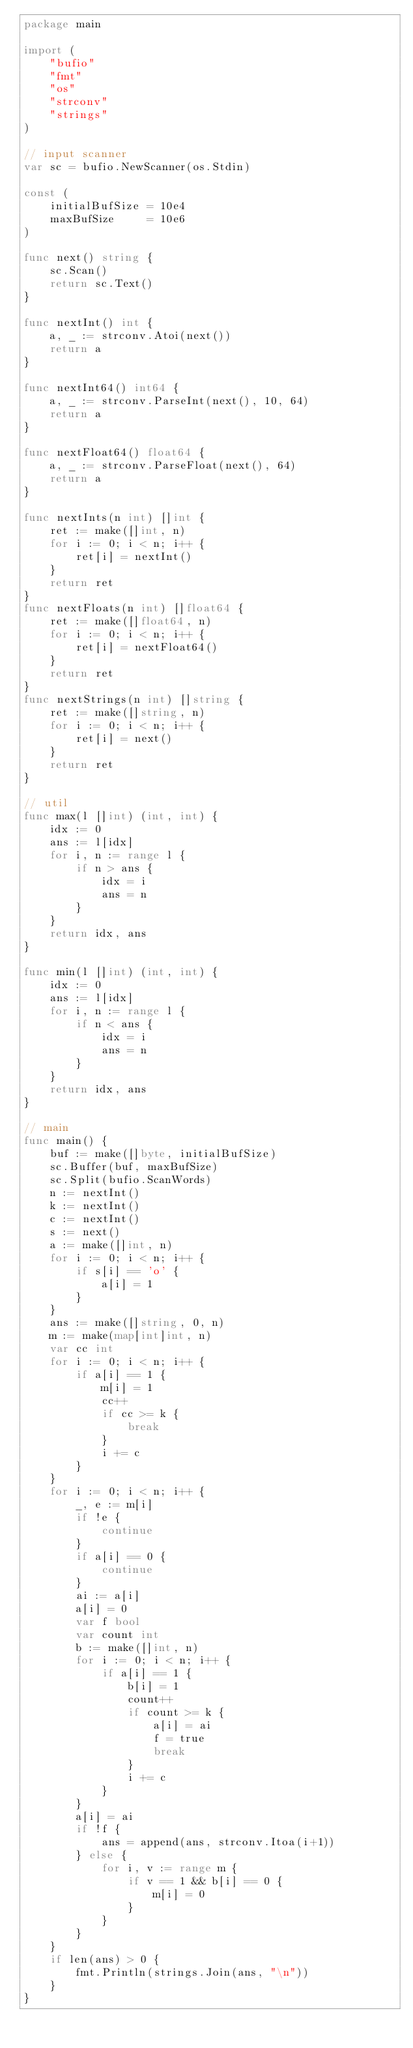<code> <loc_0><loc_0><loc_500><loc_500><_Go_>package main

import (
	"bufio"
	"fmt"
	"os"
	"strconv"
	"strings"
)

// input scanner
var sc = bufio.NewScanner(os.Stdin)

const (
	initialBufSize = 10e4
	maxBufSize     = 10e6
)

func next() string {
	sc.Scan()
	return sc.Text()
}

func nextInt() int {
	a, _ := strconv.Atoi(next())
	return a
}

func nextInt64() int64 {
	a, _ := strconv.ParseInt(next(), 10, 64)
	return a
}

func nextFloat64() float64 {
	a, _ := strconv.ParseFloat(next(), 64)
	return a
}

func nextInts(n int) []int {
	ret := make([]int, n)
	for i := 0; i < n; i++ {
		ret[i] = nextInt()
	}
	return ret
}
func nextFloats(n int) []float64 {
	ret := make([]float64, n)
	for i := 0; i < n; i++ {
		ret[i] = nextFloat64()
	}
	return ret
}
func nextStrings(n int) []string {
	ret := make([]string, n)
	for i := 0; i < n; i++ {
		ret[i] = next()
	}
	return ret
}

// util
func max(l []int) (int, int) {
	idx := 0
	ans := l[idx]
	for i, n := range l {
		if n > ans {
			idx = i
			ans = n
		}
	}
	return idx, ans
}

func min(l []int) (int, int) {
	idx := 0
	ans := l[idx]
	for i, n := range l {
		if n < ans {
			idx = i
			ans = n
		}
	}
	return idx, ans
}

// main
func main() {
	buf := make([]byte, initialBufSize)
	sc.Buffer(buf, maxBufSize)
	sc.Split(bufio.ScanWords)
	n := nextInt()
	k := nextInt()
	c := nextInt()
	s := next()
	a := make([]int, n)
	for i := 0; i < n; i++ {
		if s[i] == 'o' {
			a[i] = 1
		}
	}
	ans := make([]string, 0, n)
	m := make(map[int]int, n)
	var cc int
	for i := 0; i < n; i++ {
		if a[i] == 1 {
			m[i] = 1
			cc++
			if cc >= k {
				break
			}
			i += c
		}
	}
	for i := 0; i < n; i++ {
		_, e := m[i]
		if !e {
			continue
		}
		if a[i] == 0 {
			continue
		}
		ai := a[i]
		a[i] = 0
		var f bool
		var count int
		b := make([]int, n)
		for i := 0; i < n; i++ {
			if a[i] == 1 {
				b[i] = 1
				count++
				if count >= k {
					a[i] = ai
					f = true
					break
				}
				i += c
			}
		}
		a[i] = ai
		if !f {
			ans = append(ans, strconv.Itoa(i+1))
		} else {
			for i, v := range m {
				if v == 1 && b[i] == 0 {
					m[i] = 0
				}
			}
		}
	}
	if len(ans) > 0 {
		fmt.Println(strings.Join(ans, "\n"))
	}
}
</code> 